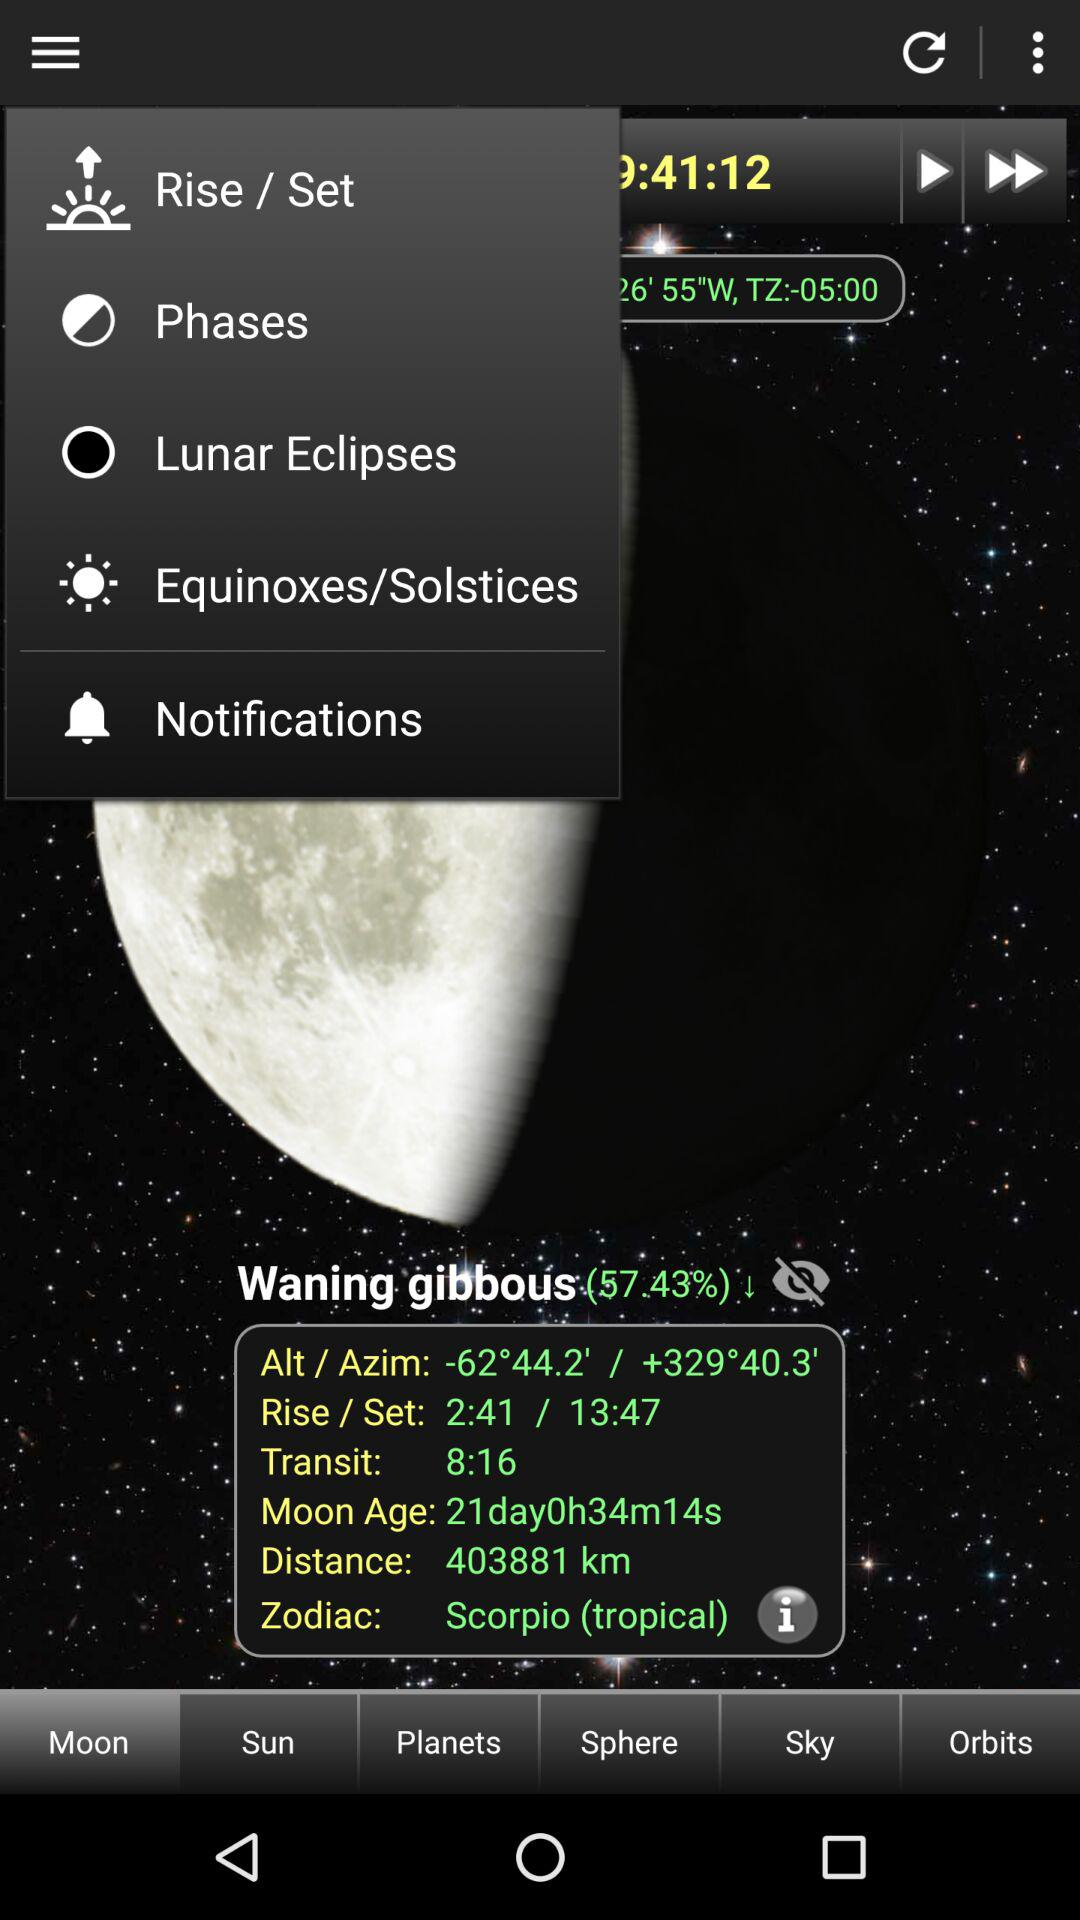What is the setting time? The setting time is 13:47. 